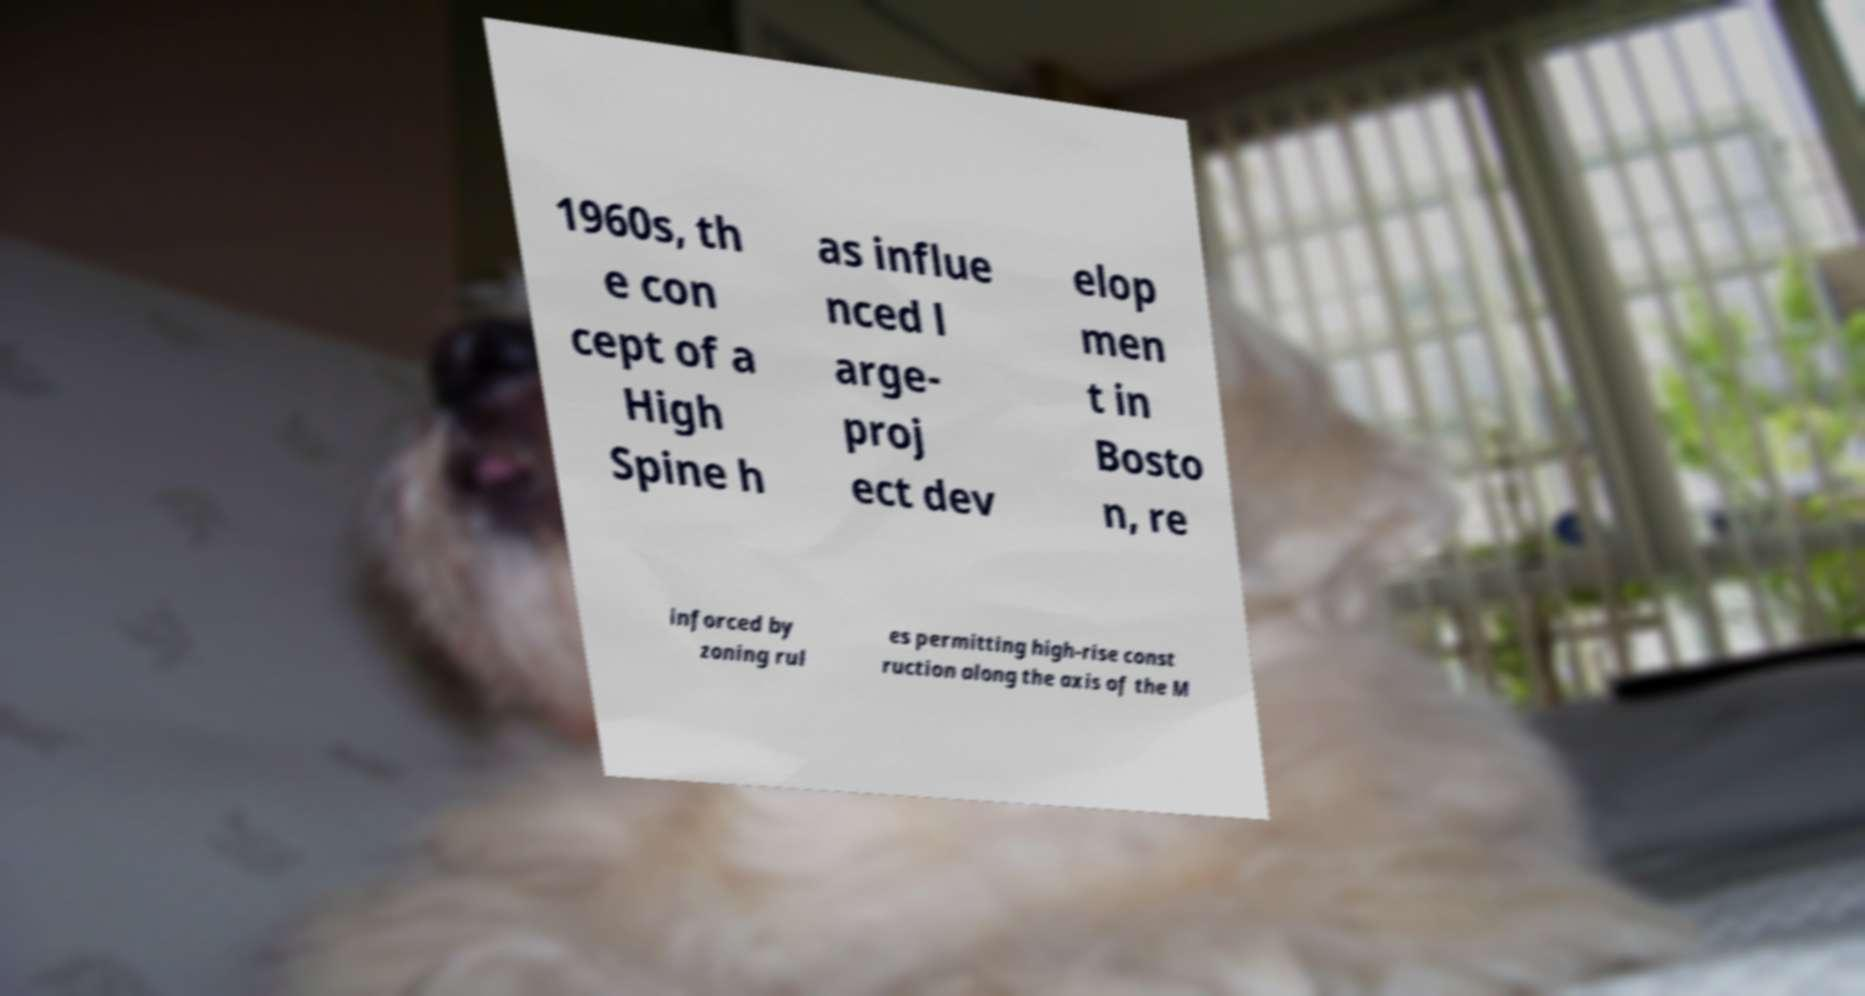Can you accurately transcribe the text from the provided image for me? 1960s, th e con cept of a High Spine h as influe nced l arge- proj ect dev elop men t in Bosto n, re inforced by zoning rul es permitting high-rise const ruction along the axis of the M 